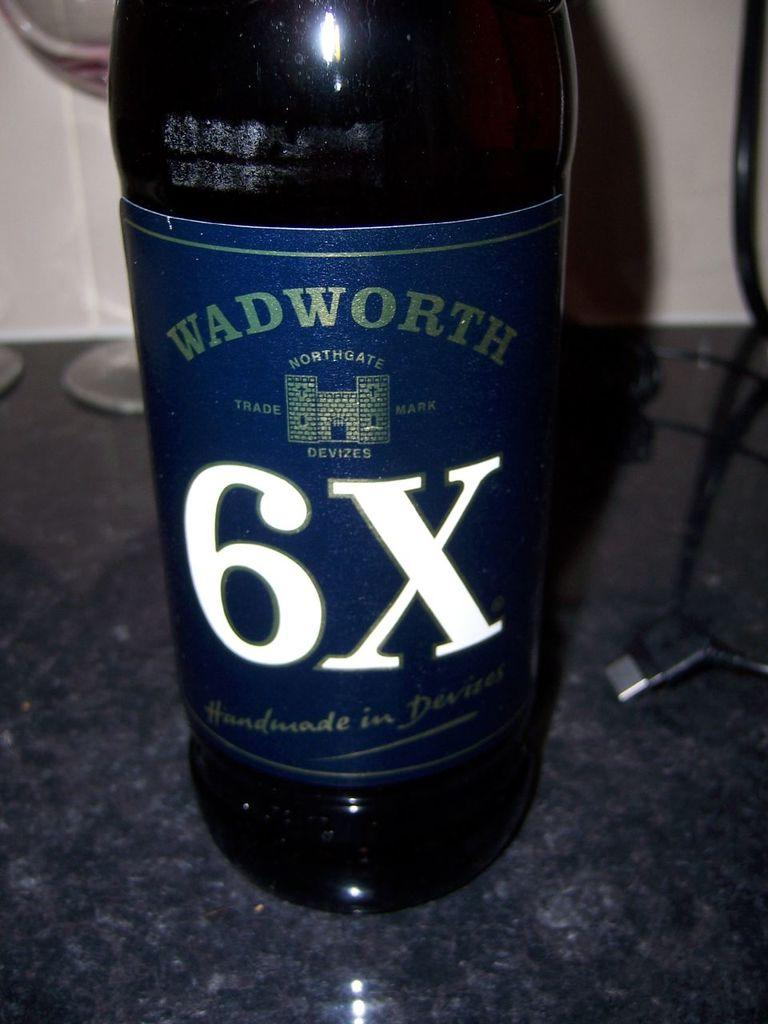<image>
Create a compact narrative representing the image presented. A bottle of Wadworth 6X sits on top of a dark granite counter 